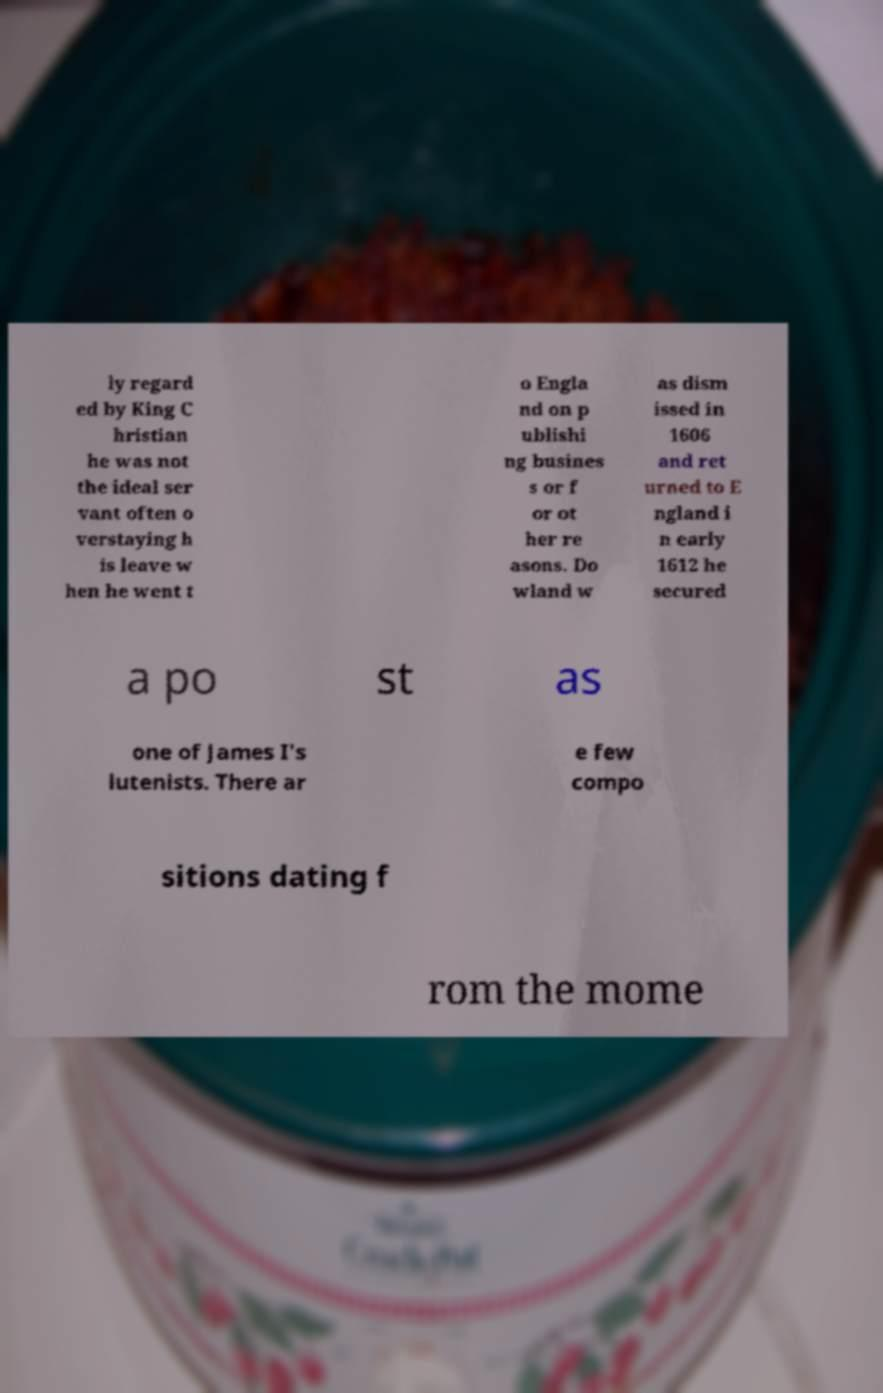What messages or text are displayed in this image? I need them in a readable, typed format. ly regard ed by King C hristian he was not the ideal ser vant often o verstaying h is leave w hen he went t o Engla nd on p ublishi ng busines s or f or ot her re asons. Do wland w as dism issed in 1606 and ret urned to E ngland i n early 1612 he secured a po st as one of James I's lutenists. There ar e few compo sitions dating f rom the mome 